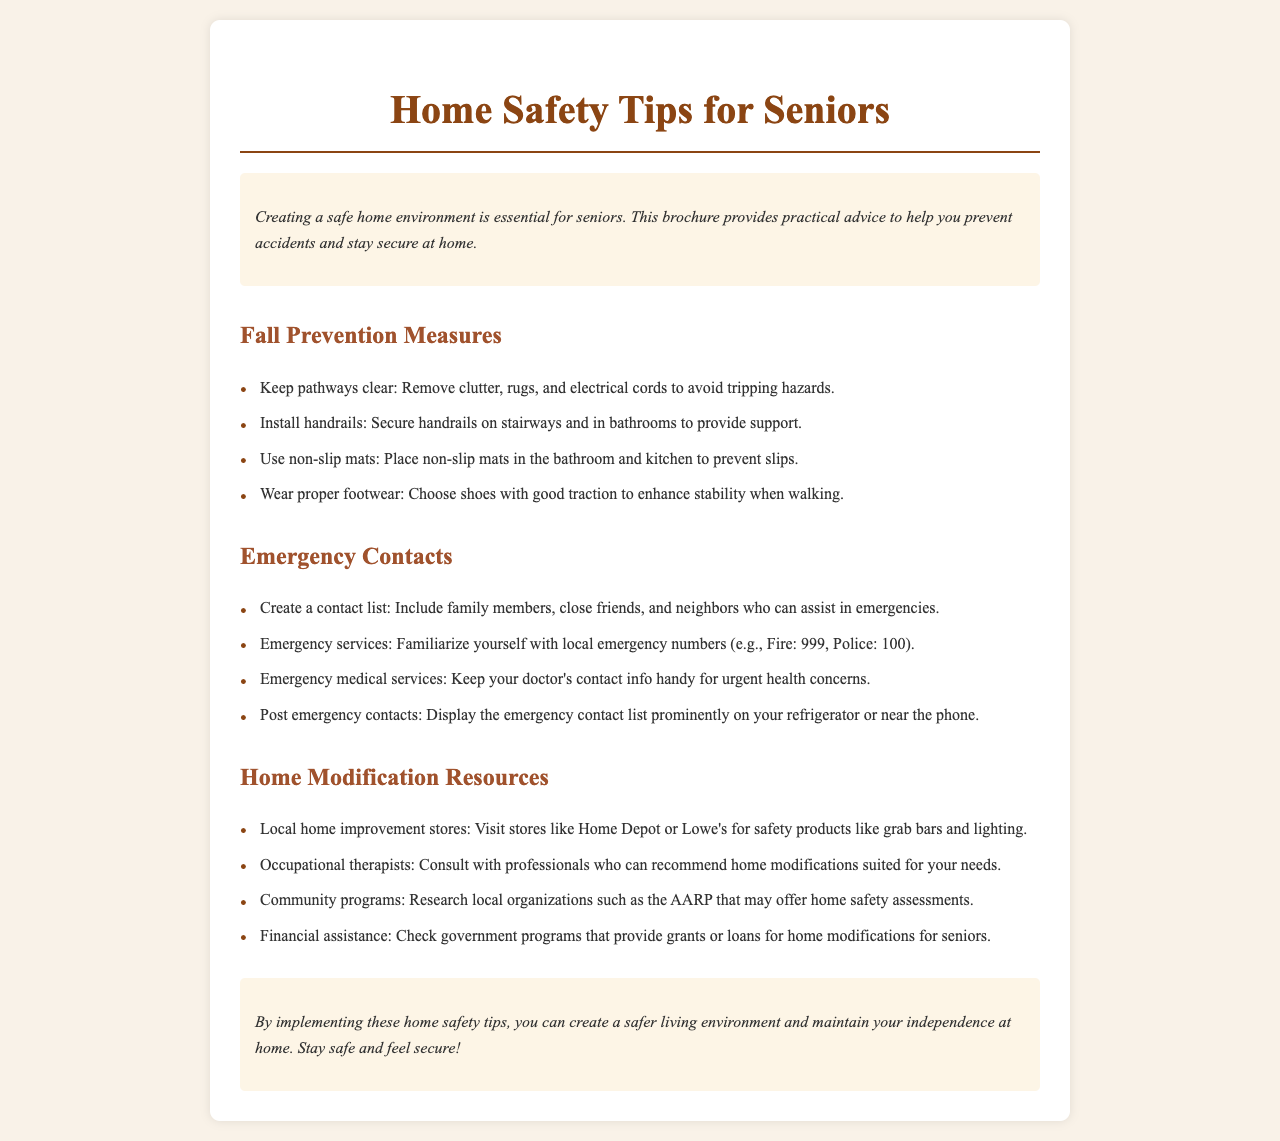What is the title of the brochure? The title is clearly indicated at the top of the document, which is "Home Safety Tips for Seniors."
Answer: Home Safety Tips for Seniors What is one fall prevention measure mentioned? The brochure lists several measures under fall prevention, such as keeping pathways clear.
Answer: Keep pathways clear What emergency service number is mentioned for Fire? The document includes local emergency service numbers, specifically mentioning the number for Fire emergencies.
Answer: 999 Who can assist in emergencies according to the document? The brochure suggests creating a contact list that includes family members, close friends, and neighbors.
Answer: Family members, close friends, and neighbors What is one resource for home modification? The document outlines several resources, including local home improvement stores.
Answer: Local home improvement stores What should be done with emergency contacts? The brochure advises that emergency contacts should be displayed prominently for easy access.
Answer: Display prominently What type of professional can recommend home modifications? The brochure mentions consulting with occupational therapists as a resource for home modifications.
Answer: Occupational therapists What is the purpose of implementing these home safety tips? The conclusion of the brochure explains that the safety tips help maintain independence and create a safer living environment.
Answer: Maintain independence What type of environment does the brochure promote for seniors? The overall message of the brochure emphasizes the creation of a safe home environment for seniors.
Answer: Safe home environment 